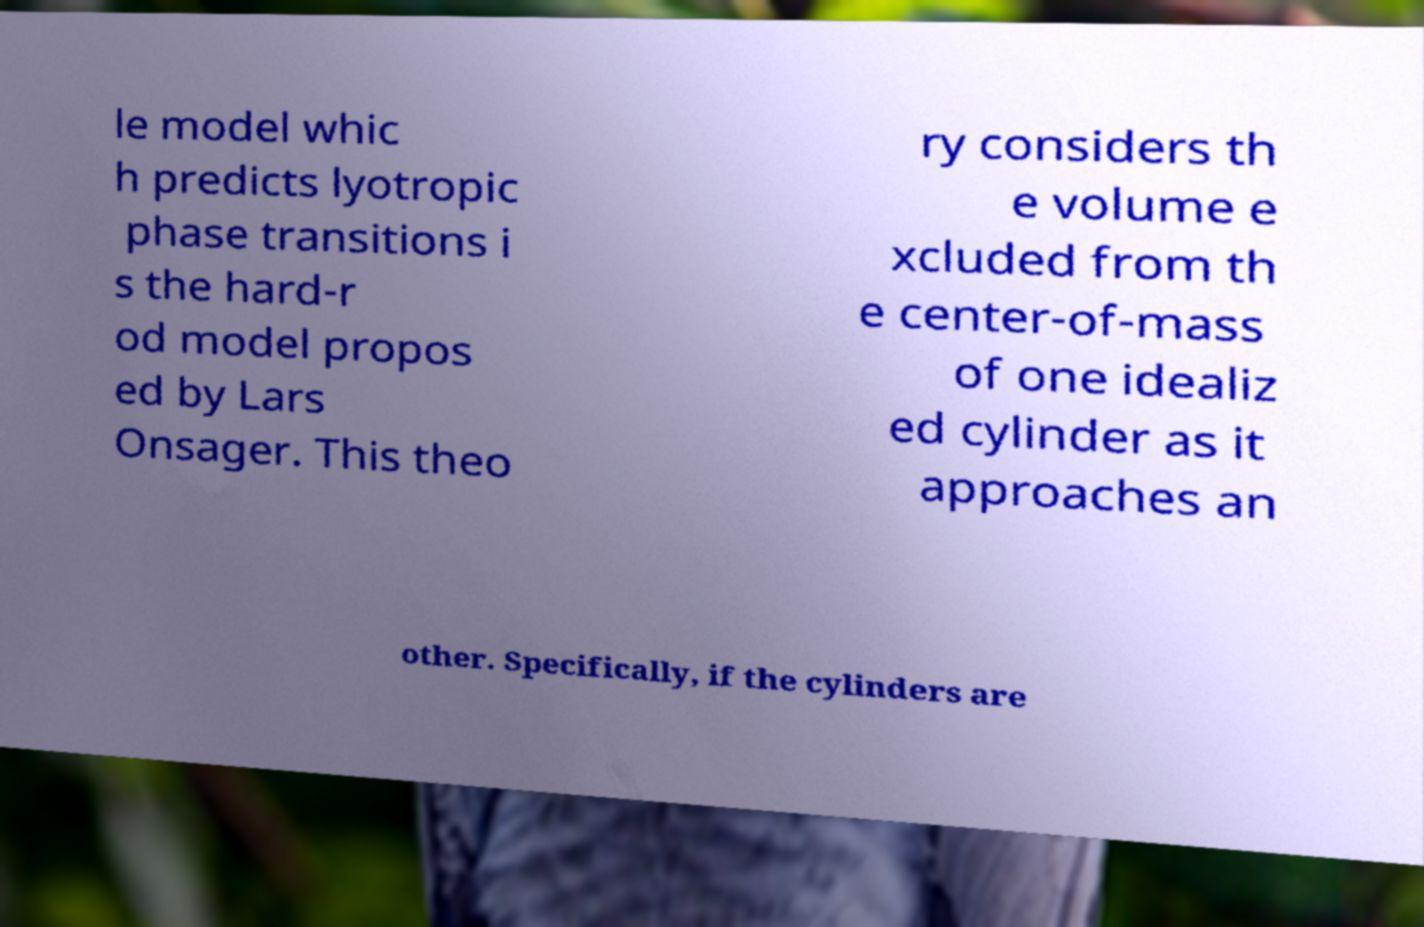Could you assist in decoding the text presented in this image and type it out clearly? le model whic h predicts lyotropic phase transitions i s the hard-r od model propos ed by Lars Onsager. This theo ry considers th e volume e xcluded from th e center-of-mass of one idealiz ed cylinder as it approaches an other. Specifically, if the cylinders are 